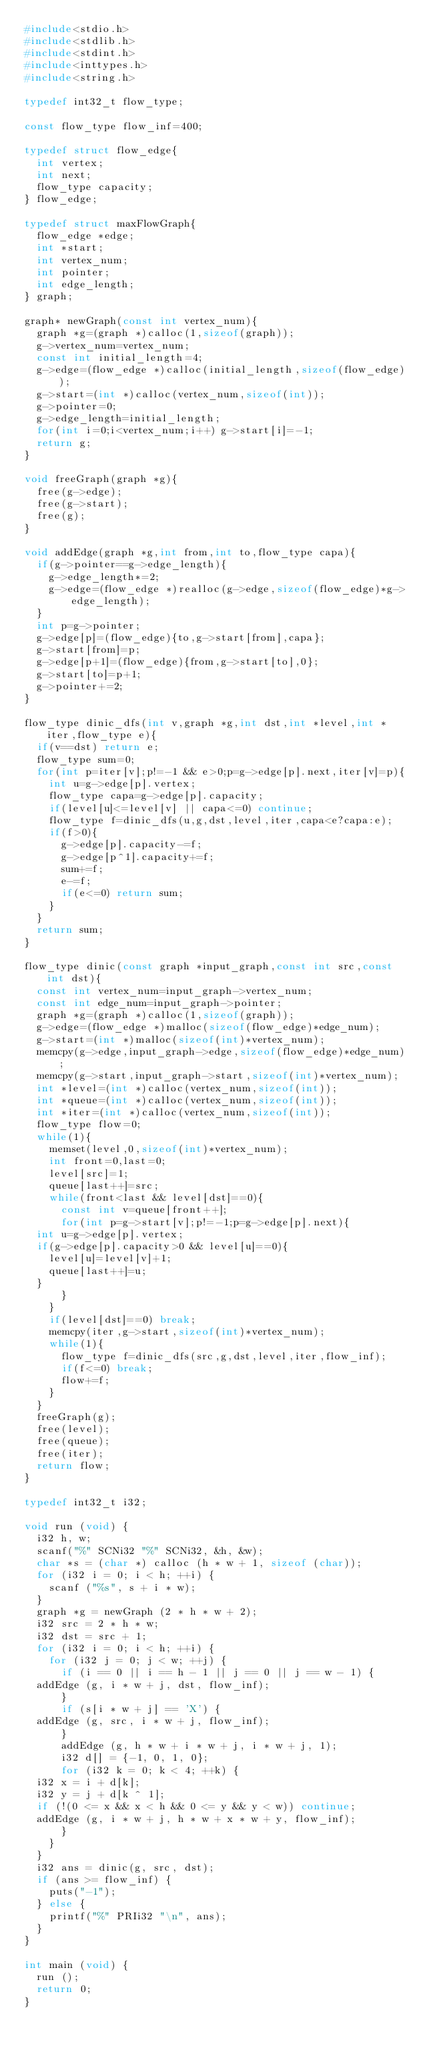<code> <loc_0><loc_0><loc_500><loc_500><_C_>#include<stdio.h>
#include<stdlib.h>
#include<stdint.h>
#include<inttypes.h>
#include<string.h>

typedef int32_t flow_type;

const flow_type flow_inf=400;

typedef struct flow_edge{
  int vertex;
  int next;
  flow_type capacity;
} flow_edge;

typedef struct maxFlowGraph{
  flow_edge *edge;
  int *start;
  int vertex_num;
  int pointer;
  int edge_length;
} graph;

graph* newGraph(const int vertex_num){
  graph *g=(graph *)calloc(1,sizeof(graph));
  g->vertex_num=vertex_num;
  const int initial_length=4;
  g->edge=(flow_edge *)calloc(initial_length,sizeof(flow_edge));
  g->start=(int *)calloc(vertex_num,sizeof(int));
  g->pointer=0;
  g->edge_length=initial_length;
  for(int i=0;i<vertex_num;i++) g->start[i]=-1;
  return g;
}

void freeGraph(graph *g){
  free(g->edge);
  free(g->start);
  free(g);
}

void addEdge(graph *g,int from,int to,flow_type capa){
  if(g->pointer==g->edge_length){
    g->edge_length*=2;
    g->edge=(flow_edge *)realloc(g->edge,sizeof(flow_edge)*g->edge_length);
  }
  int p=g->pointer;
  g->edge[p]=(flow_edge){to,g->start[from],capa};
  g->start[from]=p;
  g->edge[p+1]=(flow_edge){from,g->start[to],0};
  g->start[to]=p+1;
  g->pointer+=2;
}

flow_type dinic_dfs(int v,graph *g,int dst,int *level,int *iter,flow_type e){
  if(v==dst) return e;
  flow_type sum=0;
  for(int p=iter[v];p!=-1 && e>0;p=g->edge[p].next,iter[v]=p){
    int u=g->edge[p].vertex;
    flow_type capa=g->edge[p].capacity;
    if(level[u]<=level[v] || capa<=0) continue;
    flow_type f=dinic_dfs(u,g,dst,level,iter,capa<e?capa:e);
    if(f>0){
      g->edge[p].capacity-=f;
      g->edge[p^1].capacity+=f;
      sum+=f;
      e-=f;
      if(e<=0) return sum;
    }
  }
  return sum;
}

flow_type dinic(const graph *input_graph,const int src,const int dst){
  const int vertex_num=input_graph->vertex_num;
  const int edge_num=input_graph->pointer;
  graph *g=(graph *)calloc(1,sizeof(graph));
  g->edge=(flow_edge *)malloc(sizeof(flow_edge)*edge_num);
  g->start=(int *)malloc(sizeof(int)*vertex_num);
  memcpy(g->edge,input_graph->edge,sizeof(flow_edge)*edge_num);
  memcpy(g->start,input_graph->start,sizeof(int)*vertex_num);
  int *level=(int *)calloc(vertex_num,sizeof(int));
  int *queue=(int *)calloc(vertex_num,sizeof(int));
  int *iter=(int *)calloc(vertex_num,sizeof(int));
  flow_type flow=0;
  while(1){
    memset(level,0,sizeof(int)*vertex_num);
    int front=0,last=0;
    level[src]=1;
    queue[last++]=src;
    while(front<last && level[dst]==0){
      const int v=queue[front++];
      for(int p=g->start[v];p!=-1;p=g->edge[p].next){
	int u=g->edge[p].vertex;
	if(g->edge[p].capacity>0 && level[u]==0){
	  level[u]=level[v]+1;
	  queue[last++]=u;
	}
      }
    }
    if(level[dst]==0) break;
    memcpy(iter,g->start,sizeof(int)*vertex_num);
    while(1){
      flow_type f=dinic_dfs(src,g,dst,level,iter,flow_inf);
      if(f<=0) break;
      flow+=f;
    }
  }
  freeGraph(g);
  free(level);
  free(queue);
  free(iter);
  return flow;
}

typedef int32_t i32;

void run (void) {
  i32 h, w;
  scanf("%" SCNi32 "%" SCNi32, &h, &w);
  char *s = (char *) calloc (h * w + 1, sizeof (char));
  for (i32 i = 0; i < h; ++i) {
    scanf ("%s", s + i * w);
  }
  graph *g = newGraph (2 * h * w + 2);
  i32 src = 2 * h * w;
  i32 dst = src + 1;
  for (i32 i = 0; i < h; ++i) {
    for (i32 j = 0; j < w; ++j) {
      if (i == 0 || i == h - 1 || j == 0 || j == w - 1) {
	addEdge (g, i * w + j, dst, flow_inf);
      }
      if (s[i * w + j] == 'X') {
	addEdge (g, src, i * w + j, flow_inf);
      }
      addEdge (g, h * w + i * w + j, i * w + j, 1);
      i32 d[] = {-1, 0, 1, 0};
      for (i32 k = 0; k < 4; ++k) {
	i32 x = i + d[k];
	i32 y = j + d[k ^ 1];
	if (!(0 <= x && x < h && 0 <= y && y < w)) continue;
	addEdge (g, i * w + j, h * w + x * w + y, flow_inf);
      }
    }
  }
  i32 ans = dinic(g, src, dst);
  if (ans >= flow_inf) {
    puts("-1");
  } else {
    printf("%" PRIi32 "\n", ans);
  }
}

int main (void) {
  run ();
  return 0;
}
</code> 